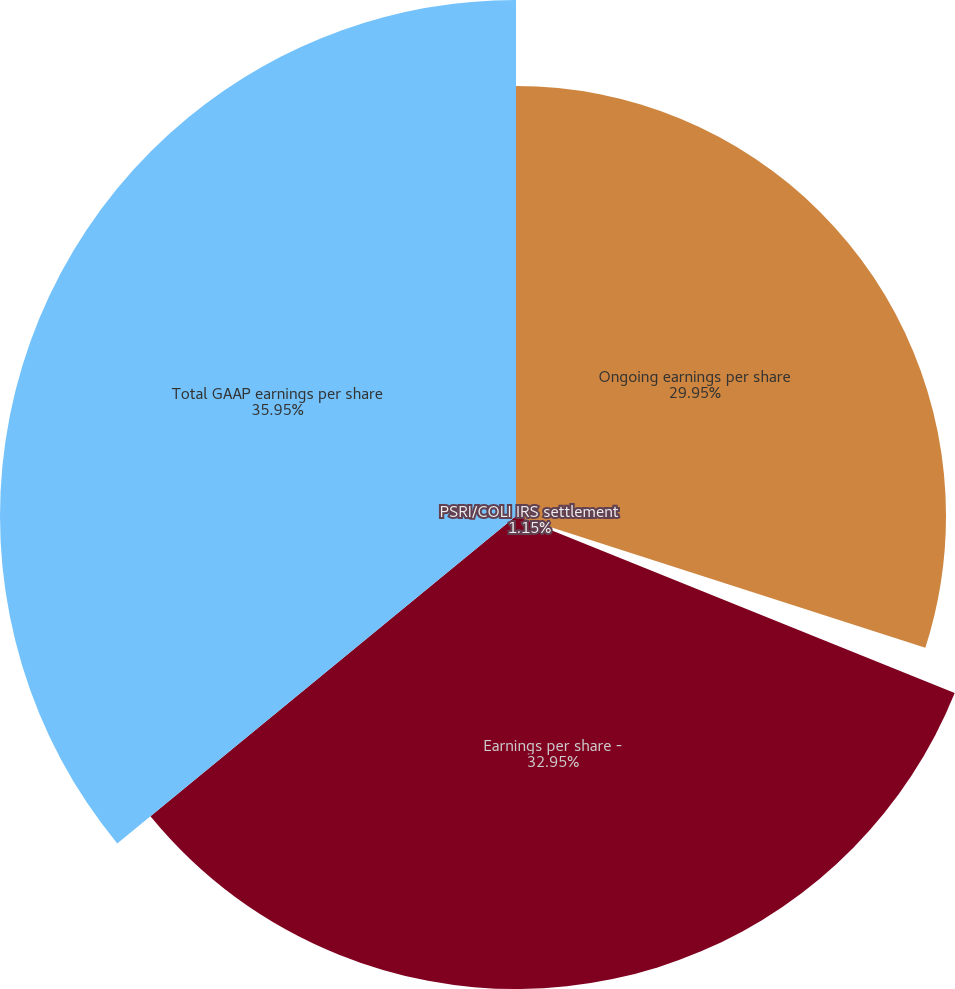<chart> <loc_0><loc_0><loc_500><loc_500><pie_chart><fcel>Ongoing earnings per share<fcel>PSRI/COLI IRS settlement<fcel>Earnings per share -<fcel>Total GAAP earnings per share<nl><fcel>29.95%<fcel>1.15%<fcel>32.95%<fcel>35.94%<nl></chart> 